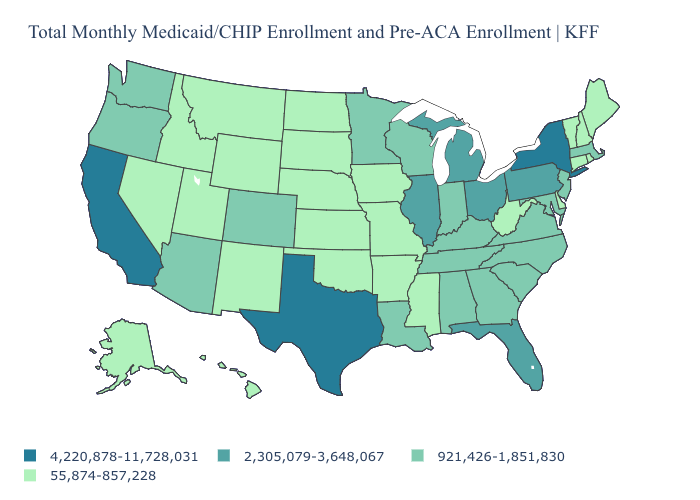Does the first symbol in the legend represent the smallest category?
Be succinct. No. What is the highest value in the USA?
Quick response, please. 4,220,878-11,728,031. What is the highest value in the West ?
Keep it brief. 4,220,878-11,728,031. Among the states that border Vermont , which have the lowest value?
Short answer required. New Hampshire. Among the states that border Kansas , which have the highest value?
Short answer required. Colorado. Name the states that have a value in the range 55,874-857,228?
Answer briefly. Alaska, Arkansas, Connecticut, Delaware, Hawaii, Idaho, Iowa, Kansas, Maine, Mississippi, Missouri, Montana, Nebraska, Nevada, New Hampshire, New Mexico, North Dakota, Oklahoma, Rhode Island, South Dakota, Utah, Vermont, West Virginia, Wyoming. Name the states that have a value in the range 55,874-857,228?
Give a very brief answer. Alaska, Arkansas, Connecticut, Delaware, Hawaii, Idaho, Iowa, Kansas, Maine, Mississippi, Missouri, Montana, Nebraska, Nevada, New Hampshire, New Mexico, North Dakota, Oklahoma, Rhode Island, South Dakota, Utah, Vermont, West Virginia, Wyoming. What is the lowest value in the Northeast?
Give a very brief answer. 55,874-857,228. Name the states that have a value in the range 55,874-857,228?
Write a very short answer. Alaska, Arkansas, Connecticut, Delaware, Hawaii, Idaho, Iowa, Kansas, Maine, Mississippi, Missouri, Montana, Nebraska, Nevada, New Hampshire, New Mexico, North Dakota, Oklahoma, Rhode Island, South Dakota, Utah, Vermont, West Virginia, Wyoming. How many symbols are there in the legend?
Write a very short answer. 4. Among the states that border Texas , does Louisiana have the highest value?
Concise answer only. Yes. What is the highest value in the West ?
Quick response, please. 4,220,878-11,728,031. What is the lowest value in states that border New York?
Answer briefly. 55,874-857,228. What is the value of Arkansas?
Write a very short answer. 55,874-857,228. 